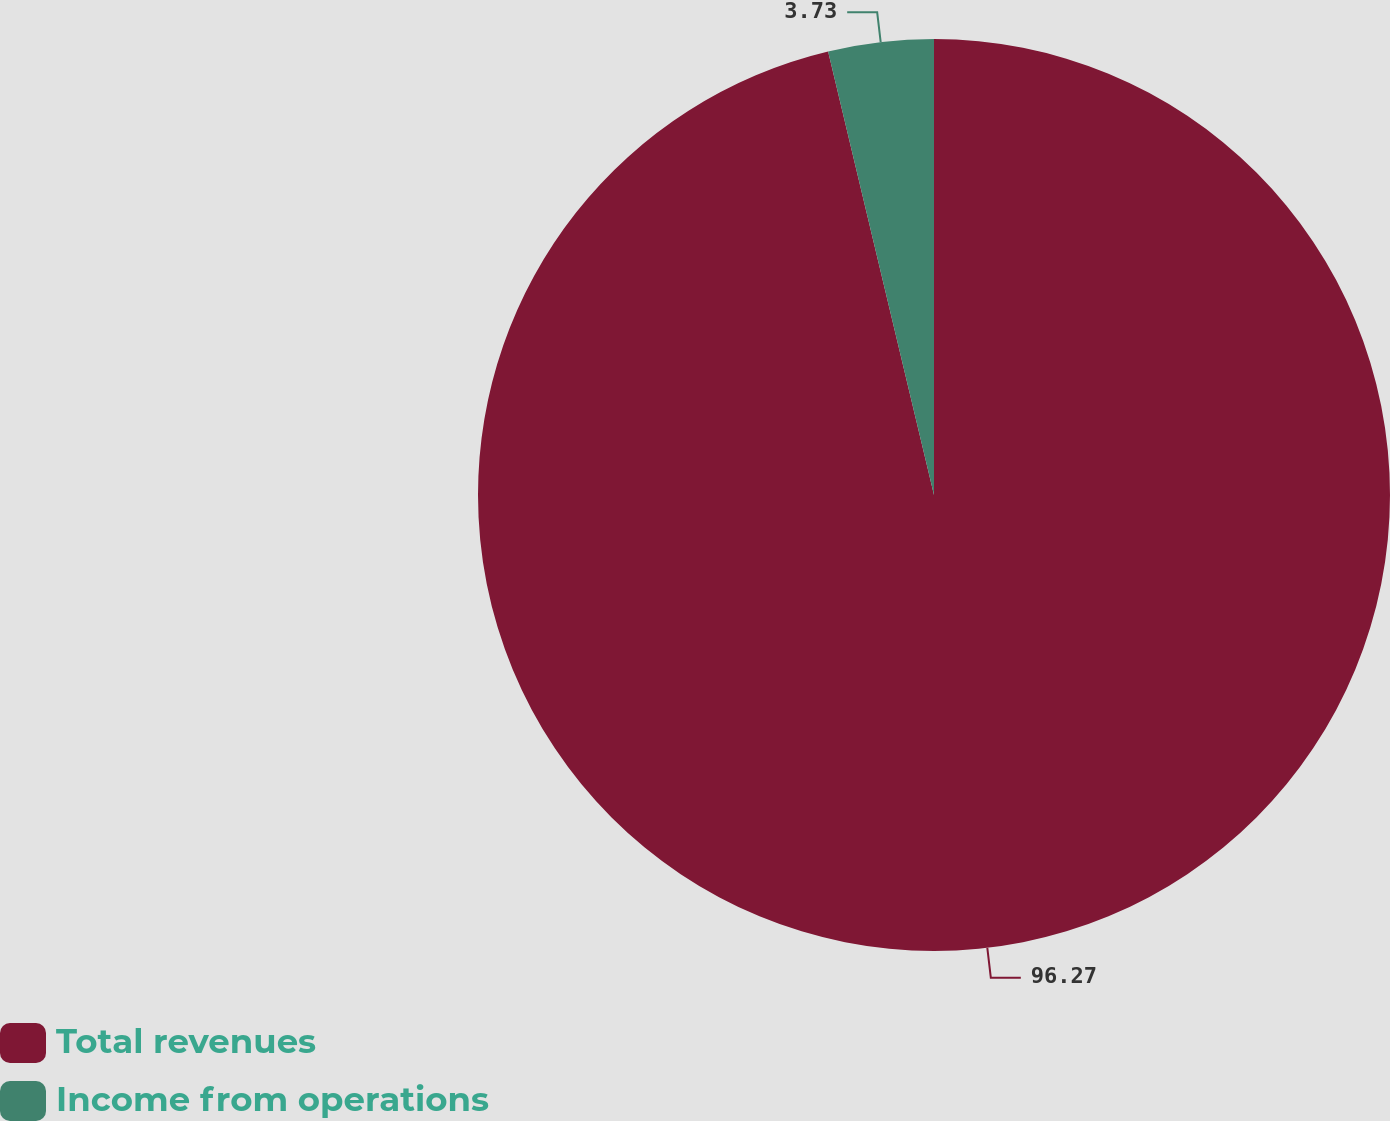Convert chart to OTSL. <chart><loc_0><loc_0><loc_500><loc_500><pie_chart><fcel>Total revenues<fcel>Income from operations<nl><fcel>96.27%<fcel>3.73%<nl></chart> 